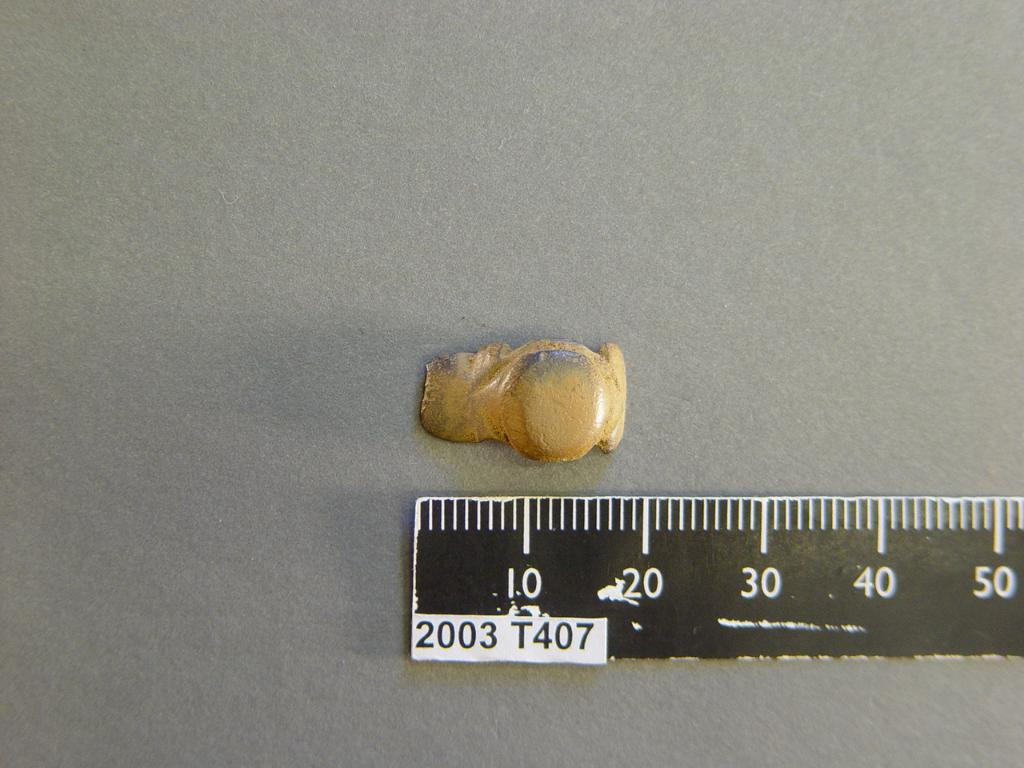<image>
Relay a brief, clear account of the picture shown. a yellow colored material place above to the ruler which has 2003 T407 on it 